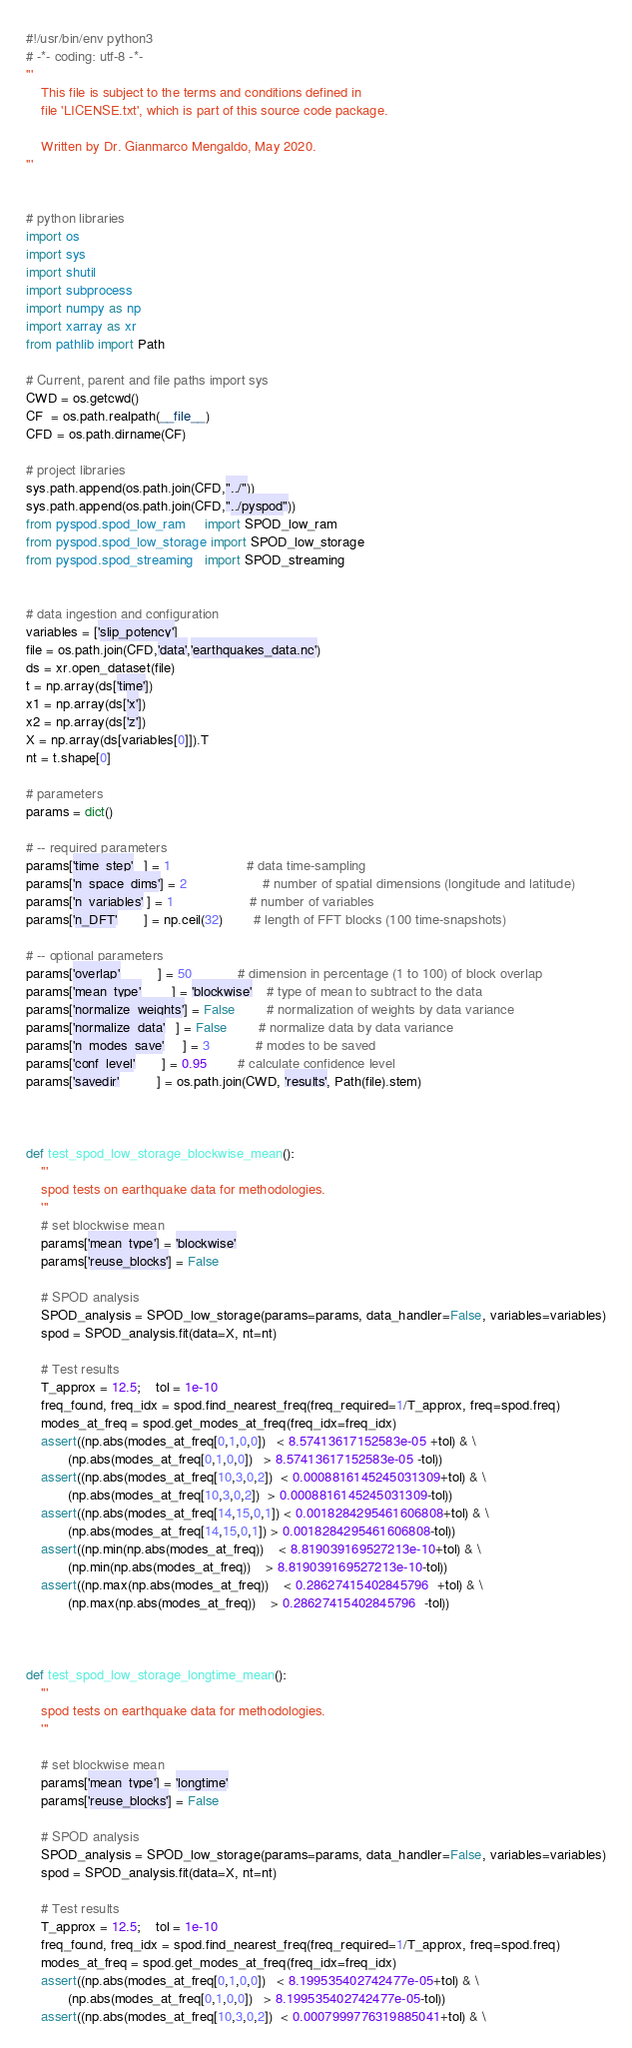<code> <loc_0><loc_0><loc_500><loc_500><_Python_>#!/usr/bin/env python3
# -*- coding: utf-8 -*-
'''
	This file is subject to the terms and conditions defined in
	file 'LICENSE.txt', which is part of this source code package.

	Written by Dr. Gianmarco Mengaldo, May 2020.
'''


# python libraries
import os
import sys
import shutil
import subprocess
import numpy as np
import xarray as xr
from pathlib import Path

# Current, parent and file paths import sys
CWD = os.getcwd()
CF  = os.path.realpath(__file__)
CFD = os.path.dirname(CF)

# project libraries
sys.path.append(os.path.join(CFD,"../"))
sys.path.append(os.path.join(CFD,"../pyspod"))
from pyspod.spod_low_ram     import SPOD_low_ram
from pyspod.spod_low_storage import SPOD_low_storage
from pyspod.spod_streaming   import SPOD_streaming


# data ingestion and configuration
variables = ['slip_potency']
file = os.path.join(CFD,'data','earthquakes_data.nc')
ds = xr.open_dataset(file)
t = np.array(ds['time'])
x1 = np.array(ds['x'])
x2 = np.array(ds['z'])
X = np.array(ds[variables[0]]).T
nt = t.shape[0] 

# parameters
params = dict()

# -- required parameters
params['time_step'   ] = 1 					# data time-sampling
params['n_space_dims'] = 2 					# number of spatial dimensions (longitude and latitude)
params['n_variables' ] = 1 					# number of variables
params['n_DFT'       ] = np.ceil(32) 		# length of FFT blocks (100 time-snapshots)

# -- optional parameters
params['overlap'          ] = 50			# dimension in percentage (1 to 100) of block overlap
params['mean_type'        ] = 'blockwise' 	# type of mean to subtract to the data
params['normalize_weights'] = False       	# normalization of weights by data variance
params['normalize_data'   ] = False  		# normalize data by data variance
params['n_modes_save'     ] = 3      		# modes to be saved
params['conf_level'       ] = 0.95   		# calculate confidence level
params['savedir'          ] = os.path.join(CWD, 'results', Path(file).stem)



def test_spod_low_storage_blockwise_mean():
	'''
	spod tests on earthquake data for methodologies.
	'''
	# set blockwise mean
	params['mean_type'] = 'blockwise'
	params['reuse_blocks'] = False

	# SPOD analysis
	SPOD_analysis = SPOD_low_storage(params=params, data_handler=False, variables=variables)
	spod = SPOD_analysis.fit(data=X, nt=nt)

	# Test results
	T_approx = 12.5; 	tol = 1e-10
	freq_found, freq_idx = spod.find_nearest_freq(freq_required=1/T_approx, freq=spod.freq)
	modes_at_freq = spod.get_modes_at_freq(freq_idx=freq_idx)
	assert((np.abs(modes_at_freq[0,1,0,0])   < 8.57413617152583e-05 +tol) & \
		   (np.abs(modes_at_freq[0,1,0,0])   > 8.57413617152583e-05 -tol))
	assert((np.abs(modes_at_freq[10,3,0,2])  < 0.0008816145245031309+tol) & \
		   (np.abs(modes_at_freq[10,3,0,2])  > 0.0008816145245031309-tol))
	assert((np.abs(modes_at_freq[14,15,0,1]) < 0.0018284295461606808+tol) & \
		   (np.abs(modes_at_freq[14,15,0,1]) > 0.0018284295461606808-tol))
	assert((np.min(np.abs(modes_at_freq))    < 8.819039169527213e-10+tol) & \
		   (np.min(np.abs(modes_at_freq))    > 8.819039169527213e-10-tol))
	assert((np.max(np.abs(modes_at_freq))    < 0.28627415402845796  +tol) & \
		   (np.max(np.abs(modes_at_freq))    > 0.28627415402845796  -tol))



def test_spod_low_storage_longtime_mean():
	'''
	spod tests on earthquake data for methodologies.
	'''

	# set blockwise mean
	params['mean_type'] = 'longtime'
	params['reuse_blocks'] = False

	# SPOD analysis
	SPOD_analysis = SPOD_low_storage(params=params, data_handler=False, variables=variables)
	spod = SPOD_analysis.fit(data=X, nt=nt)

	# Test results
	T_approx = 12.5; 	tol = 1e-10
	freq_found, freq_idx = spod.find_nearest_freq(freq_required=1/T_approx, freq=spod.freq)
	modes_at_freq = spod.get_modes_at_freq(freq_idx=freq_idx)
	assert((np.abs(modes_at_freq[0,1,0,0])   < 8.199535402742477e-05+tol) & \
		   (np.abs(modes_at_freq[0,1,0,0])   > 8.199535402742477e-05-tol))
	assert((np.abs(modes_at_freq[10,3,0,2])  < 0.0007999776319885041+tol) & \</code> 